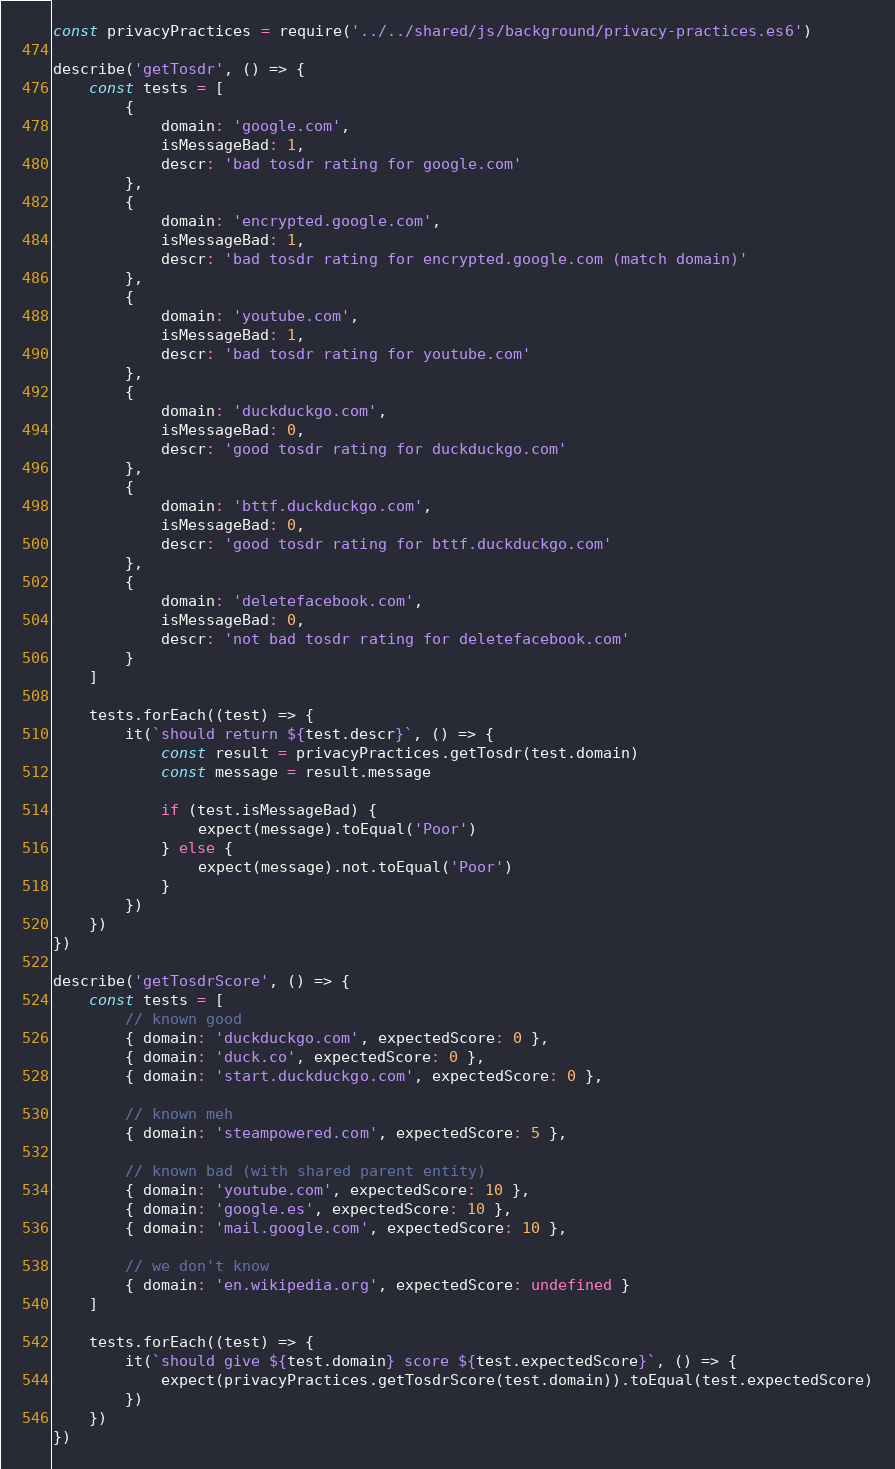Convert code to text. <code><loc_0><loc_0><loc_500><loc_500><_JavaScript_>const privacyPractices = require('../../shared/js/background/privacy-practices.es6')

describe('getTosdr', () => {
    const tests = [
        {
            domain: 'google.com',
            isMessageBad: 1,
            descr: 'bad tosdr rating for google.com'
        },
        {
            domain: 'encrypted.google.com',
            isMessageBad: 1,
            descr: 'bad tosdr rating for encrypted.google.com (match domain)'
        },
        {
            domain: 'youtube.com',
            isMessageBad: 1,
            descr: 'bad tosdr rating for youtube.com'
        },
        {
            domain: 'duckduckgo.com',
            isMessageBad: 0,
            descr: 'good tosdr rating for duckduckgo.com'
        },
        {
            domain: 'bttf.duckduckgo.com',
            isMessageBad: 0,
            descr: 'good tosdr rating for bttf.duckduckgo.com'
        },
        {
            domain: 'deletefacebook.com',
            isMessageBad: 0,
            descr: 'not bad tosdr rating for deletefacebook.com'
        }
    ]

    tests.forEach((test) => {
        it(`should return ${test.descr}`, () => {
            const result = privacyPractices.getTosdr(test.domain)
            const message = result.message

            if (test.isMessageBad) {
                expect(message).toEqual('Poor')
            } else {
                expect(message).not.toEqual('Poor')
            }
        })
    })
})

describe('getTosdrScore', () => {
    const tests = [
        // known good
        { domain: 'duckduckgo.com', expectedScore: 0 },
        { domain: 'duck.co', expectedScore: 0 },
        { domain: 'start.duckduckgo.com', expectedScore: 0 },

        // known meh
        { domain: 'steampowered.com', expectedScore: 5 },

        // known bad (with shared parent entity)
        { domain: 'youtube.com', expectedScore: 10 },
        { domain: 'google.es', expectedScore: 10 },
        { domain: 'mail.google.com', expectedScore: 10 },

        // we don't know
        { domain: 'en.wikipedia.org', expectedScore: undefined }
    ]

    tests.forEach((test) => {
        it(`should give ${test.domain} score ${test.expectedScore}`, () => {
            expect(privacyPractices.getTosdrScore(test.domain)).toEqual(test.expectedScore)
        })
    })
})
</code> 